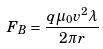Convert formula to latex. <formula><loc_0><loc_0><loc_500><loc_500>F _ { B } = \frac { q \mu _ { 0 } v ^ { 2 } \lambda } { 2 \pi r }</formula> 